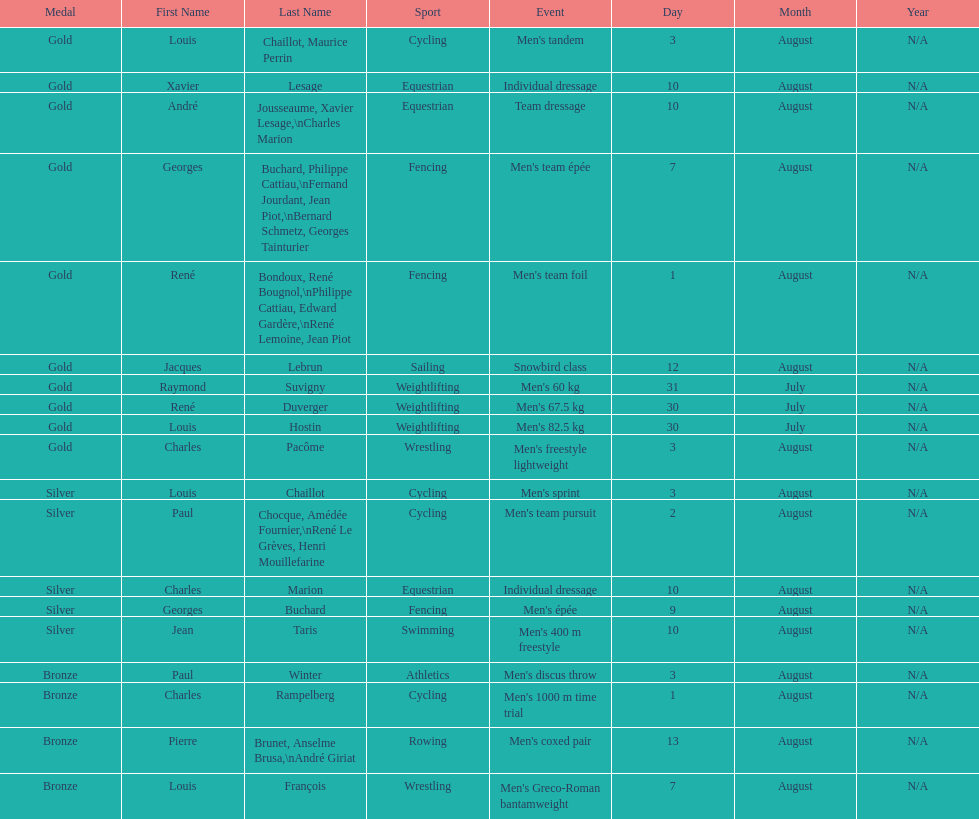How many total gold medals were won by weightlifting? 3. 